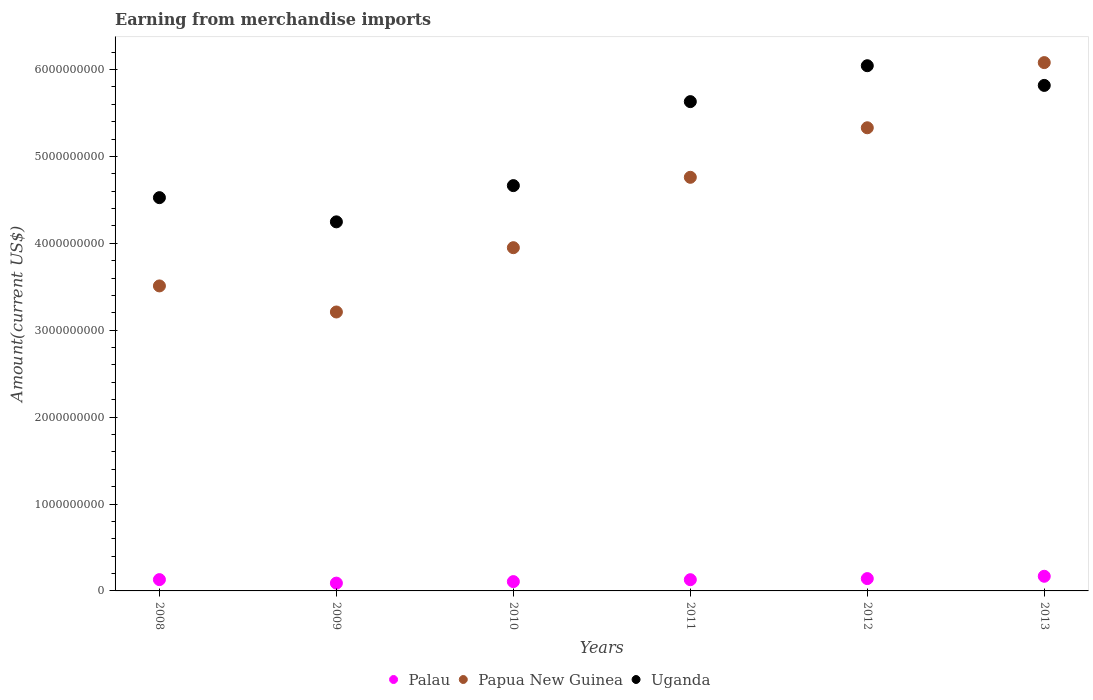Is the number of dotlines equal to the number of legend labels?
Your answer should be very brief. Yes. What is the amount earned from merchandise imports in Papua New Guinea in 2011?
Your answer should be compact. 4.76e+09. Across all years, what is the maximum amount earned from merchandise imports in Palau?
Ensure brevity in your answer.  1.69e+08. Across all years, what is the minimum amount earned from merchandise imports in Papua New Guinea?
Ensure brevity in your answer.  3.21e+09. In which year was the amount earned from merchandise imports in Papua New Guinea maximum?
Offer a terse response. 2013. What is the total amount earned from merchandise imports in Palau in the graph?
Your response must be concise. 7.67e+08. What is the difference between the amount earned from merchandise imports in Papua New Guinea in 2012 and that in 2013?
Ensure brevity in your answer.  -7.50e+08. What is the difference between the amount earned from merchandise imports in Papua New Guinea in 2010 and the amount earned from merchandise imports in Palau in 2012?
Offer a very short reply. 3.81e+09. What is the average amount earned from merchandise imports in Papua New Guinea per year?
Give a very brief answer. 4.47e+09. In the year 2013, what is the difference between the amount earned from merchandise imports in Palau and amount earned from merchandise imports in Papua New Guinea?
Your response must be concise. -5.91e+09. In how many years, is the amount earned from merchandise imports in Palau greater than 4800000000 US$?
Give a very brief answer. 0. What is the ratio of the amount earned from merchandise imports in Uganda in 2010 to that in 2013?
Offer a terse response. 0.8. Is the difference between the amount earned from merchandise imports in Palau in 2009 and 2010 greater than the difference between the amount earned from merchandise imports in Papua New Guinea in 2009 and 2010?
Give a very brief answer. Yes. What is the difference between the highest and the second highest amount earned from merchandise imports in Palau?
Make the answer very short. 2.67e+07. What is the difference between the highest and the lowest amount earned from merchandise imports in Papua New Guinea?
Provide a succinct answer. 2.87e+09. Does the amount earned from merchandise imports in Papua New Guinea monotonically increase over the years?
Offer a very short reply. No. Is the amount earned from merchandise imports in Papua New Guinea strictly greater than the amount earned from merchandise imports in Uganda over the years?
Your answer should be very brief. No. Is the amount earned from merchandise imports in Papua New Guinea strictly less than the amount earned from merchandise imports in Uganda over the years?
Provide a short and direct response. No. How many years are there in the graph?
Give a very brief answer. 6. Does the graph contain grids?
Give a very brief answer. No. Where does the legend appear in the graph?
Provide a succinct answer. Bottom center. How many legend labels are there?
Offer a very short reply. 3. How are the legend labels stacked?
Your answer should be very brief. Horizontal. What is the title of the graph?
Ensure brevity in your answer.  Earning from merchandise imports. What is the label or title of the Y-axis?
Give a very brief answer. Amount(current US$). What is the Amount(current US$) of Palau in 2008?
Provide a succinct answer. 1.30e+08. What is the Amount(current US$) in Papua New Guinea in 2008?
Offer a terse response. 3.51e+09. What is the Amount(current US$) in Uganda in 2008?
Keep it short and to the point. 4.53e+09. What is the Amount(current US$) in Palau in 2009?
Your answer should be very brief. 8.99e+07. What is the Amount(current US$) in Papua New Guinea in 2009?
Make the answer very short. 3.21e+09. What is the Amount(current US$) of Uganda in 2009?
Keep it short and to the point. 4.25e+09. What is the Amount(current US$) in Palau in 2010?
Your answer should be very brief. 1.07e+08. What is the Amount(current US$) of Papua New Guinea in 2010?
Ensure brevity in your answer.  3.95e+09. What is the Amount(current US$) in Uganda in 2010?
Offer a terse response. 4.66e+09. What is the Amount(current US$) in Palau in 2011?
Provide a succinct answer. 1.29e+08. What is the Amount(current US$) in Papua New Guinea in 2011?
Keep it short and to the point. 4.76e+09. What is the Amount(current US$) in Uganda in 2011?
Your answer should be very brief. 5.63e+09. What is the Amount(current US$) in Palau in 2012?
Provide a succinct answer. 1.42e+08. What is the Amount(current US$) of Papua New Guinea in 2012?
Your answer should be very brief. 5.33e+09. What is the Amount(current US$) in Uganda in 2012?
Provide a short and direct response. 6.04e+09. What is the Amount(current US$) of Palau in 2013?
Ensure brevity in your answer.  1.69e+08. What is the Amount(current US$) of Papua New Guinea in 2013?
Your response must be concise. 6.08e+09. What is the Amount(current US$) in Uganda in 2013?
Your answer should be compact. 5.82e+09. Across all years, what is the maximum Amount(current US$) in Palau?
Keep it short and to the point. 1.69e+08. Across all years, what is the maximum Amount(current US$) of Papua New Guinea?
Your answer should be compact. 6.08e+09. Across all years, what is the maximum Amount(current US$) in Uganda?
Keep it short and to the point. 6.04e+09. Across all years, what is the minimum Amount(current US$) of Palau?
Keep it short and to the point. 8.99e+07. Across all years, what is the minimum Amount(current US$) of Papua New Guinea?
Provide a short and direct response. 3.21e+09. Across all years, what is the minimum Amount(current US$) of Uganda?
Give a very brief answer. 4.25e+09. What is the total Amount(current US$) of Palau in the graph?
Ensure brevity in your answer.  7.67e+08. What is the total Amount(current US$) in Papua New Guinea in the graph?
Offer a terse response. 2.68e+1. What is the total Amount(current US$) of Uganda in the graph?
Provide a succinct answer. 3.09e+1. What is the difference between the Amount(current US$) of Palau in 2008 and that in 2009?
Offer a terse response. 4.02e+07. What is the difference between the Amount(current US$) in Papua New Guinea in 2008 and that in 2009?
Your answer should be very brief. 3.00e+08. What is the difference between the Amount(current US$) of Uganda in 2008 and that in 2009?
Ensure brevity in your answer.  2.78e+08. What is the difference between the Amount(current US$) in Palau in 2008 and that in 2010?
Keep it short and to the point. 2.29e+07. What is the difference between the Amount(current US$) of Papua New Guinea in 2008 and that in 2010?
Your answer should be compact. -4.40e+08. What is the difference between the Amount(current US$) of Uganda in 2008 and that in 2010?
Give a very brief answer. -1.38e+08. What is the difference between the Amount(current US$) of Palau in 2008 and that in 2011?
Your answer should be compact. 9.13e+05. What is the difference between the Amount(current US$) of Papua New Guinea in 2008 and that in 2011?
Provide a succinct answer. -1.25e+09. What is the difference between the Amount(current US$) in Uganda in 2008 and that in 2011?
Ensure brevity in your answer.  -1.11e+09. What is the difference between the Amount(current US$) in Palau in 2008 and that in 2012?
Your answer should be very brief. -1.18e+07. What is the difference between the Amount(current US$) in Papua New Guinea in 2008 and that in 2012?
Offer a very short reply. -1.82e+09. What is the difference between the Amount(current US$) of Uganda in 2008 and that in 2012?
Provide a short and direct response. -1.52e+09. What is the difference between the Amount(current US$) of Palau in 2008 and that in 2013?
Provide a short and direct response. -3.85e+07. What is the difference between the Amount(current US$) of Papua New Guinea in 2008 and that in 2013?
Offer a very short reply. -2.57e+09. What is the difference between the Amount(current US$) in Uganda in 2008 and that in 2013?
Provide a short and direct response. -1.29e+09. What is the difference between the Amount(current US$) of Palau in 2009 and that in 2010?
Give a very brief answer. -1.73e+07. What is the difference between the Amount(current US$) of Papua New Guinea in 2009 and that in 2010?
Give a very brief answer. -7.40e+08. What is the difference between the Amount(current US$) of Uganda in 2009 and that in 2010?
Your answer should be very brief. -4.17e+08. What is the difference between the Amount(current US$) of Palau in 2009 and that in 2011?
Provide a succinct answer. -3.93e+07. What is the difference between the Amount(current US$) in Papua New Guinea in 2009 and that in 2011?
Make the answer very short. -1.55e+09. What is the difference between the Amount(current US$) of Uganda in 2009 and that in 2011?
Keep it short and to the point. -1.38e+09. What is the difference between the Amount(current US$) in Palau in 2009 and that in 2012?
Your answer should be very brief. -5.20e+07. What is the difference between the Amount(current US$) in Papua New Guinea in 2009 and that in 2012?
Keep it short and to the point. -2.12e+09. What is the difference between the Amount(current US$) in Uganda in 2009 and that in 2012?
Offer a terse response. -1.80e+09. What is the difference between the Amount(current US$) of Palau in 2009 and that in 2013?
Make the answer very short. -7.87e+07. What is the difference between the Amount(current US$) of Papua New Guinea in 2009 and that in 2013?
Make the answer very short. -2.87e+09. What is the difference between the Amount(current US$) of Uganda in 2009 and that in 2013?
Provide a short and direct response. -1.57e+09. What is the difference between the Amount(current US$) of Palau in 2010 and that in 2011?
Keep it short and to the point. -2.20e+07. What is the difference between the Amount(current US$) in Papua New Guinea in 2010 and that in 2011?
Offer a terse response. -8.10e+08. What is the difference between the Amount(current US$) in Uganda in 2010 and that in 2011?
Ensure brevity in your answer.  -9.67e+08. What is the difference between the Amount(current US$) in Palau in 2010 and that in 2012?
Your response must be concise. -3.47e+07. What is the difference between the Amount(current US$) in Papua New Guinea in 2010 and that in 2012?
Ensure brevity in your answer.  -1.38e+09. What is the difference between the Amount(current US$) of Uganda in 2010 and that in 2012?
Keep it short and to the point. -1.38e+09. What is the difference between the Amount(current US$) in Palau in 2010 and that in 2013?
Keep it short and to the point. -6.14e+07. What is the difference between the Amount(current US$) in Papua New Guinea in 2010 and that in 2013?
Make the answer very short. -2.13e+09. What is the difference between the Amount(current US$) of Uganda in 2010 and that in 2013?
Provide a short and direct response. -1.15e+09. What is the difference between the Amount(current US$) in Palau in 2011 and that in 2012?
Make the answer very short. -1.27e+07. What is the difference between the Amount(current US$) in Papua New Guinea in 2011 and that in 2012?
Keep it short and to the point. -5.70e+08. What is the difference between the Amount(current US$) in Uganda in 2011 and that in 2012?
Offer a very short reply. -4.13e+08. What is the difference between the Amount(current US$) of Palau in 2011 and that in 2013?
Offer a terse response. -3.94e+07. What is the difference between the Amount(current US$) in Papua New Guinea in 2011 and that in 2013?
Ensure brevity in your answer.  -1.32e+09. What is the difference between the Amount(current US$) of Uganda in 2011 and that in 2013?
Provide a succinct answer. -1.87e+08. What is the difference between the Amount(current US$) of Palau in 2012 and that in 2013?
Your response must be concise. -2.67e+07. What is the difference between the Amount(current US$) in Papua New Guinea in 2012 and that in 2013?
Provide a succinct answer. -7.50e+08. What is the difference between the Amount(current US$) in Uganda in 2012 and that in 2013?
Your answer should be compact. 2.27e+08. What is the difference between the Amount(current US$) of Palau in 2008 and the Amount(current US$) of Papua New Guinea in 2009?
Your answer should be very brief. -3.08e+09. What is the difference between the Amount(current US$) of Palau in 2008 and the Amount(current US$) of Uganda in 2009?
Offer a terse response. -4.12e+09. What is the difference between the Amount(current US$) in Papua New Guinea in 2008 and the Amount(current US$) in Uganda in 2009?
Keep it short and to the point. -7.37e+08. What is the difference between the Amount(current US$) of Palau in 2008 and the Amount(current US$) of Papua New Guinea in 2010?
Offer a very short reply. -3.82e+09. What is the difference between the Amount(current US$) of Palau in 2008 and the Amount(current US$) of Uganda in 2010?
Provide a short and direct response. -4.53e+09. What is the difference between the Amount(current US$) of Papua New Guinea in 2008 and the Amount(current US$) of Uganda in 2010?
Ensure brevity in your answer.  -1.15e+09. What is the difference between the Amount(current US$) in Palau in 2008 and the Amount(current US$) in Papua New Guinea in 2011?
Give a very brief answer. -4.63e+09. What is the difference between the Amount(current US$) of Palau in 2008 and the Amount(current US$) of Uganda in 2011?
Make the answer very short. -5.50e+09. What is the difference between the Amount(current US$) in Papua New Guinea in 2008 and the Amount(current US$) in Uganda in 2011?
Give a very brief answer. -2.12e+09. What is the difference between the Amount(current US$) in Palau in 2008 and the Amount(current US$) in Papua New Guinea in 2012?
Offer a very short reply. -5.20e+09. What is the difference between the Amount(current US$) in Palau in 2008 and the Amount(current US$) in Uganda in 2012?
Give a very brief answer. -5.91e+09. What is the difference between the Amount(current US$) of Papua New Guinea in 2008 and the Amount(current US$) of Uganda in 2012?
Provide a short and direct response. -2.53e+09. What is the difference between the Amount(current US$) in Palau in 2008 and the Amount(current US$) in Papua New Guinea in 2013?
Make the answer very short. -5.95e+09. What is the difference between the Amount(current US$) in Palau in 2008 and the Amount(current US$) in Uganda in 2013?
Make the answer very short. -5.69e+09. What is the difference between the Amount(current US$) in Papua New Guinea in 2008 and the Amount(current US$) in Uganda in 2013?
Ensure brevity in your answer.  -2.31e+09. What is the difference between the Amount(current US$) of Palau in 2009 and the Amount(current US$) of Papua New Guinea in 2010?
Offer a terse response. -3.86e+09. What is the difference between the Amount(current US$) of Palau in 2009 and the Amount(current US$) of Uganda in 2010?
Make the answer very short. -4.57e+09. What is the difference between the Amount(current US$) of Papua New Guinea in 2009 and the Amount(current US$) of Uganda in 2010?
Your answer should be very brief. -1.45e+09. What is the difference between the Amount(current US$) of Palau in 2009 and the Amount(current US$) of Papua New Guinea in 2011?
Ensure brevity in your answer.  -4.67e+09. What is the difference between the Amount(current US$) in Palau in 2009 and the Amount(current US$) in Uganda in 2011?
Your answer should be compact. -5.54e+09. What is the difference between the Amount(current US$) of Papua New Guinea in 2009 and the Amount(current US$) of Uganda in 2011?
Your response must be concise. -2.42e+09. What is the difference between the Amount(current US$) of Palau in 2009 and the Amount(current US$) of Papua New Guinea in 2012?
Your answer should be very brief. -5.24e+09. What is the difference between the Amount(current US$) in Palau in 2009 and the Amount(current US$) in Uganda in 2012?
Your answer should be compact. -5.95e+09. What is the difference between the Amount(current US$) in Papua New Guinea in 2009 and the Amount(current US$) in Uganda in 2012?
Provide a short and direct response. -2.83e+09. What is the difference between the Amount(current US$) in Palau in 2009 and the Amount(current US$) in Papua New Guinea in 2013?
Give a very brief answer. -5.99e+09. What is the difference between the Amount(current US$) of Palau in 2009 and the Amount(current US$) of Uganda in 2013?
Your response must be concise. -5.73e+09. What is the difference between the Amount(current US$) of Papua New Guinea in 2009 and the Amount(current US$) of Uganda in 2013?
Provide a succinct answer. -2.61e+09. What is the difference between the Amount(current US$) of Palau in 2010 and the Amount(current US$) of Papua New Guinea in 2011?
Provide a short and direct response. -4.65e+09. What is the difference between the Amount(current US$) of Palau in 2010 and the Amount(current US$) of Uganda in 2011?
Keep it short and to the point. -5.52e+09. What is the difference between the Amount(current US$) in Papua New Guinea in 2010 and the Amount(current US$) in Uganda in 2011?
Give a very brief answer. -1.68e+09. What is the difference between the Amount(current US$) in Palau in 2010 and the Amount(current US$) in Papua New Guinea in 2012?
Give a very brief answer. -5.22e+09. What is the difference between the Amount(current US$) of Palau in 2010 and the Amount(current US$) of Uganda in 2012?
Offer a terse response. -5.94e+09. What is the difference between the Amount(current US$) in Papua New Guinea in 2010 and the Amount(current US$) in Uganda in 2012?
Keep it short and to the point. -2.09e+09. What is the difference between the Amount(current US$) in Palau in 2010 and the Amount(current US$) in Papua New Guinea in 2013?
Your answer should be compact. -5.97e+09. What is the difference between the Amount(current US$) of Palau in 2010 and the Amount(current US$) of Uganda in 2013?
Ensure brevity in your answer.  -5.71e+09. What is the difference between the Amount(current US$) in Papua New Guinea in 2010 and the Amount(current US$) in Uganda in 2013?
Ensure brevity in your answer.  -1.87e+09. What is the difference between the Amount(current US$) in Palau in 2011 and the Amount(current US$) in Papua New Guinea in 2012?
Make the answer very short. -5.20e+09. What is the difference between the Amount(current US$) in Palau in 2011 and the Amount(current US$) in Uganda in 2012?
Offer a very short reply. -5.91e+09. What is the difference between the Amount(current US$) in Papua New Guinea in 2011 and the Amount(current US$) in Uganda in 2012?
Your answer should be compact. -1.28e+09. What is the difference between the Amount(current US$) of Palau in 2011 and the Amount(current US$) of Papua New Guinea in 2013?
Ensure brevity in your answer.  -5.95e+09. What is the difference between the Amount(current US$) in Palau in 2011 and the Amount(current US$) in Uganda in 2013?
Give a very brief answer. -5.69e+09. What is the difference between the Amount(current US$) in Papua New Guinea in 2011 and the Amount(current US$) in Uganda in 2013?
Give a very brief answer. -1.06e+09. What is the difference between the Amount(current US$) of Palau in 2012 and the Amount(current US$) of Papua New Guinea in 2013?
Provide a short and direct response. -5.94e+09. What is the difference between the Amount(current US$) of Palau in 2012 and the Amount(current US$) of Uganda in 2013?
Ensure brevity in your answer.  -5.68e+09. What is the difference between the Amount(current US$) of Papua New Guinea in 2012 and the Amount(current US$) of Uganda in 2013?
Provide a short and direct response. -4.88e+08. What is the average Amount(current US$) in Palau per year?
Make the answer very short. 1.28e+08. What is the average Amount(current US$) of Papua New Guinea per year?
Ensure brevity in your answer.  4.47e+09. What is the average Amount(current US$) in Uganda per year?
Your response must be concise. 5.16e+09. In the year 2008, what is the difference between the Amount(current US$) of Palau and Amount(current US$) of Papua New Guinea?
Offer a very short reply. -3.38e+09. In the year 2008, what is the difference between the Amount(current US$) of Palau and Amount(current US$) of Uganda?
Keep it short and to the point. -4.40e+09. In the year 2008, what is the difference between the Amount(current US$) of Papua New Guinea and Amount(current US$) of Uganda?
Ensure brevity in your answer.  -1.02e+09. In the year 2009, what is the difference between the Amount(current US$) of Palau and Amount(current US$) of Papua New Guinea?
Make the answer very short. -3.12e+09. In the year 2009, what is the difference between the Amount(current US$) in Palau and Amount(current US$) in Uganda?
Ensure brevity in your answer.  -4.16e+09. In the year 2009, what is the difference between the Amount(current US$) of Papua New Guinea and Amount(current US$) of Uganda?
Provide a short and direct response. -1.04e+09. In the year 2010, what is the difference between the Amount(current US$) in Palau and Amount(current US$) in Papua New Guinea?
Your response must be concise. -3.84e+09. In the year 2010, what is the difference between the Amount(current US$) in Palau and Amount(current US$) in Uganda?
Make the answer very short. -4.56e+09. In the year 2010, what is the difference between the Amount(current US$) of Papua New Guinea and Amount(current US$) of Uganda?
Make the answer very short. -7.14e+08. In the year 2011, what is the difference between the Amount(current US$) of Palau and Amount(current US$) of Papua New Guinea?
Your answer should be very brief. -4.63e+09. In the year 2011, what is the difference between the Amount(current US$) in Palau and Amount(current US$) in Uganda?
Provide a succinct answer. -5.50e+09. In the year 2011, what is the difference between the Amount(current US$) in Papua New Guinea and Amount(current US$) in Uganda?
Give a very brief answer. -8.71e+08. In the year 2012, what is the difference between the Amount(current US$) of Palau and Amount(current US$) of Papua New Guinea?
Offer a terse response. -5.19e+09. In the year 2012, what is the difference between the Amount(current US$) of Palau and Amount(current US$) of Uganda?
Ensure brevity in your answer.  -5.90e+09. In the year 2012, what is the difference between the Amount(current US$) of Papua New Guinea and Amount(current US$) of Uganda?
Provide a succinct answer. -7.14e+08. In the year 2013, what is the difference between the Amount(current US$) in Palau and Amount(current US$) in Papua New Guinea?
Your answer should be compact. -5.91e+09. In the year 2013, what is the difference between the Amount(current US$) of Palau and Amount(current US$) of Uganda?
Offer a terse response. -5.65e+09. In the year 2013, what is the difference between the Amount(current US$) of Papua New Guinea and Amount(current US$) of Uganda?
Your response must be concise. 2.62e+08. What is the ratio of the Amount(current US$) in Palau in 2008 to that in 2009?
Offer a very short reply. 1.45. What is the ratio of the Amount(current US$) in Papua New Guinea in 2008 to that in 2009?
Your answer should be compact. 1.09. What is the ratio of the Amount(current US$) in Uganda in 2008 to that in 2009?
Offer a terse response. 1.07. What is the ratio of the Amount(current US$) in Palau in 2008 to that in 2010?
Your response must be concise. 1.21. What is the ratio of the Amount(current US$) in Papua New Guinea in 2008 to that in 2010?
Ensure brevity in your answer.  0.89. What is the ratio of the Amount(current US$) of Uganda in 2008 to that in 2010?
Ensure brevity in your answer.  0.97. What is the ratio of the Amount(current US$) in Palau in 2008 to that in 2011?
Your answer should be compact. 1.01. What is the ratio of the Amount(current US$) of Papua New Guinea in 2008 to that in 2011?
Your response must be concise. 0.74. What is the ratio of the Amount(current US$) in Uganda in 2008 to that in 2011?
Ensure brevity in your answer.  0.8. What is the ratio of the Amount(current US$) in Palau in 2008 to that in 2012?
Offer a very short reply. 0.92. What is the ratio of the Amount(current US$) in Papua New Guinea in 2008 to that in 2012?
Make the answer very short. 0.66. What is the ratio of the Amount(current US$) of Uganda in 2008 to that in 2012?
Make the answer very short. 0.75. What is the ratio of the Amount(current US$) of Palau in 2008 to that in 2013?
Ensure brevity in your answer.  0.77. What is the ratio of the Amount(current US$) of Papua New Guinea in 2008 to that in 2013?
Provide a succinct answer. 0.58. What is the ratio of the Amount(current US$) in Uganda in 2008 to that in 2013?
Your answer should be very brief. 0.78. What is the ratio of the Amount(current US$) of Palau in 2009 to that in 2010?
Your response must be concise. 0.84. What is the ratio of the Amount(current US$) in Papua New Guinea in 2009 to that in 2010?
Give a very brief answer. 0.81. What is the ratio of the Amount(current US$) of Uganda in 2009 to that in 2010?
Offer a very short reply. 0.91. What is the ratio of the Amount(current US$) in Palau in 2009 to that in 2011?
Make the answer very short. 0.7. What is the ratio of the Amount(current US$) of Papua New Guinea in 2009 to that in 2011?
Make the answer very short. 0.67. What is the ratio of the Amount(current US$) in Uganda in 2009 to that in 2011?
Make the answer very short. 0.75. What is the ratio of the Amount(current US$) of Palau in 2009 to that in 2012?
Your response must be concise. 0.63. What is the ratio of the Amount(current US$) of Papua New Guinea in 2009 to that in 2012?
Make the answer very short. 0.6. What is the ratio of the Amount(current US$) in Uganda in 2009 to that in 2012?
Offer a very short reply. 0.7. What is the ratio of the Amount(current US$) of Palau in 2009 to that in 2013?
Your response must be concise. 0.53. What is the ratio of the Amount(current US$) in Papua New Guinea in 2009 to that in 2013?
Offer a terse response. 0.53. What is the ratio of the Amount(current US$) of Uganda in 2009 to that in 2013?
Your answer should be very brief. 0.73. What is the ratio of the Amount(current US$) of Palau in 2010 to that in 2011?
Your answer should be compact. 0.83. What is the ratio of the Amount(current US$) in Papua New Guinea in 2010 to that in 2011?
Give a very brief answer. 0.83. What is the ratio of the Amount(current US$) in Uganda in 2010 to that in 2011?
Your response must be concise. 0.83. What is the ratio of the Amount(current US$) of Palau in 2010 to that in 2012?
Offer a very short reply. 0.76. What is the ratio of the Amount(current US$) in Papua New Guinea in 2010 to that in 2012?
Your answer should be compact. 0.74. What is the ratio of the Amount(current US$) of Uganda in 2010 to that in 2012?
Offer a terse response. 0.77. What is the ratio of the Amount(current US$) in Palau in 2010 to that in 2013?
Give a very brief answer. 0.64. What is the ratio of the Amount(current US$) in Papua New Guinea in 2010 to that in 2013?
Provide a short and direct response. 0.65. What is the ratio of the Amount(current US$) in Uganda in 2010 to that in 2013?
Provide a succinct answer. 0.8. What is the ratio of the Amount(current US$) of Palau in 2011 to that in 2012?
Offer a terse response. 0.91. What is the ratio of the Amount(current US$) in Papua New Guinea in 2011 to that in 2012?
Your response must be concise. 0.89. What is the ratio of the Amount(current US$) in Uganda in 2011 to that in 2012?
Your answer should be very brief. 0.93. What is the ratio of the Amount(current US$) of Palau in 2011 to that in 2013?
Your answer should be compact. 0.77. What is the ratio of the Amount(current US$) of Papua New Guinea in 2011 to that in 2013?
Offer a terse response. 0.78. What is the ratio of the Amount(current US$) in Uganda in 2011 to that in 2013?
Your answer should be compact. 0.97. What is the ratio of the Amount(current US$) in Palau in 2012 to that in 2013?
Offer a very short reply. 0.84. What is the ratio of the Amount(current US$) in Papua New Guinea in 2012 to that in 2013?
Offer a very short reply. 0.88. What is the ratio of the Amount(current US$) of Uganda in 2012 to that in 2013?
Provide a short and direct response. 1.04. What is the difference between the highest and the second highest Amount(current US$) of Palau?
Give a very brief answer. 2.67e+07. What is the difference between the highest and the second highest Amount(current US$) of Papua New Guinea?
Make the answer very short. 7.50e+08. What is the difference between the highest and the second highest Amount(current US$) in Uganda?
Your answer should be compact. 2.27e+08. What is the difference between the highest and the lowest Amount(current US$) in Palau?
Provide a succinct answer. 7.87e+07. What is the difference between the highest and the lowest Amount(current US$) of Papua New Guinea?
Your answer should be very brief. 2.87e+09. What is the difference between the highest and the lowest Amount(current US$) in Uganda?
Make the answer very short. 1.80e+09. 